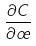Convert formula to latex. <formula><loc_0><loc_0><loc_500><loc_500>\frac { \partial C } { \partial \sigma }</formula> 